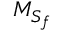Convert formula to latex. <formula><loc_0><loc_0><loc_500><loc_500>{ M } _ { { S } _ { f } }</formula> 